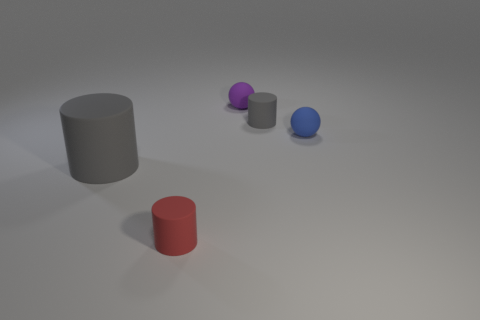There is a gray matte cylinder on the right side of the purple rubber thing; how many red matte cylinders are in front of it?
Your response must be concise. 1. What shape is the object that is to the right of the tiny gray cylinder behind the big rubber object?
Your response must be concise. Sphere. There is a gray object that is to the right of the tiny purple object; what is its size?
Your response must be concise. Small. Is the material of the tiny red object the same as the purple sphere?
Offer a very short reply. Yes. What shape is the large gray object that is the same material as the red cylinder?
Offer a terse response. Cylinder. The tiny rubber ball that is behind the small blue sphere is what color?
Your response must be concise. Purple. Is the color of the small rubber cylinder behind the blue matte thing the same as the big rubber cylinder?
Your response must be concise. Yes. What number of red things have the same size as the purple sphere?
Make the answer very short. 1. What shape is the tiny gray thing?
Give a very brief answer. Cylinder. What is the size of the rubber thing that is both left of the tiny gray matte thing and behind the big gray matte thing?
Make the answer very short. Small. 